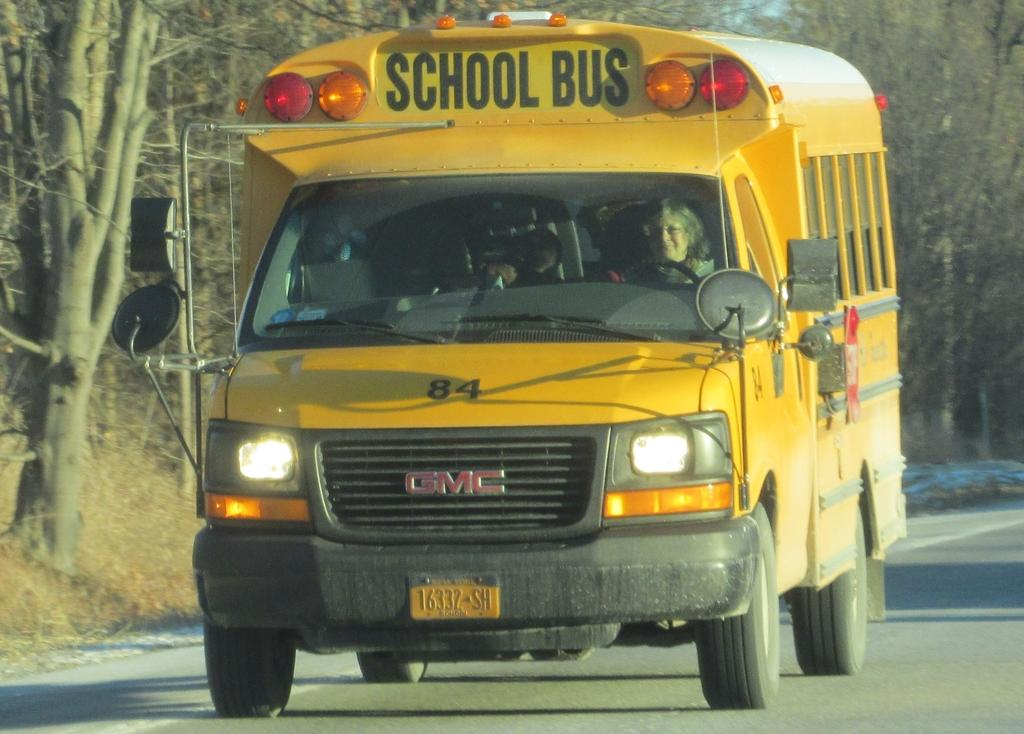<image>
Create a compact narrative representing the image presented. A yellow school bus that has the number 84 on the front hood. 